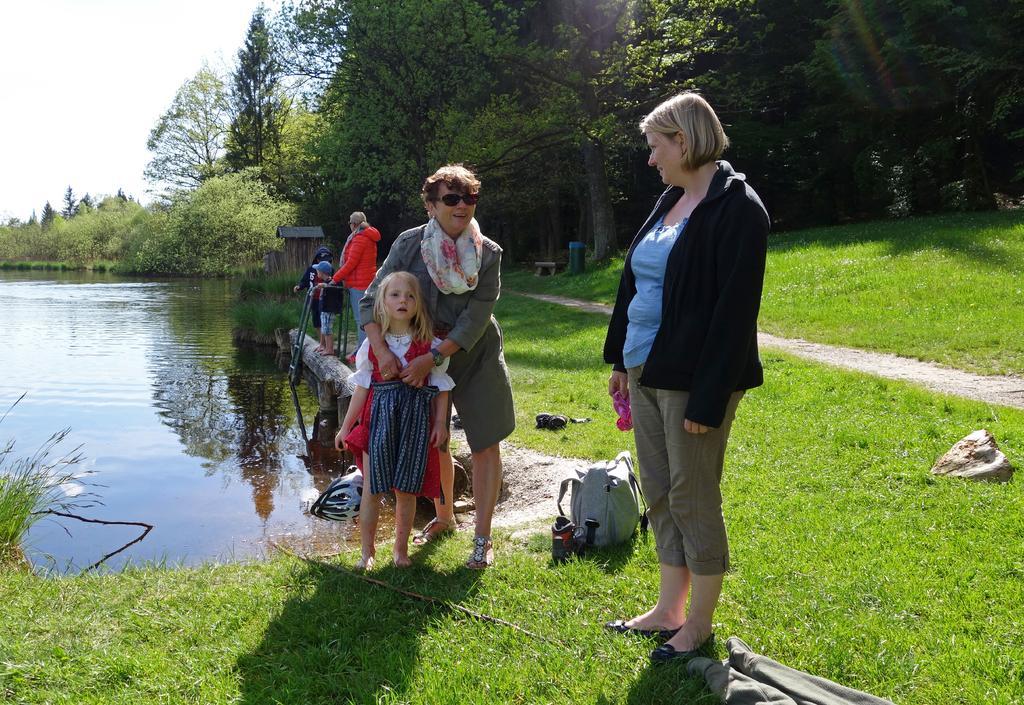Describe this image in one or two sentences. In this image there are group of people standing, and there are some items on the grass, water, trees, and in the background there is sky. 